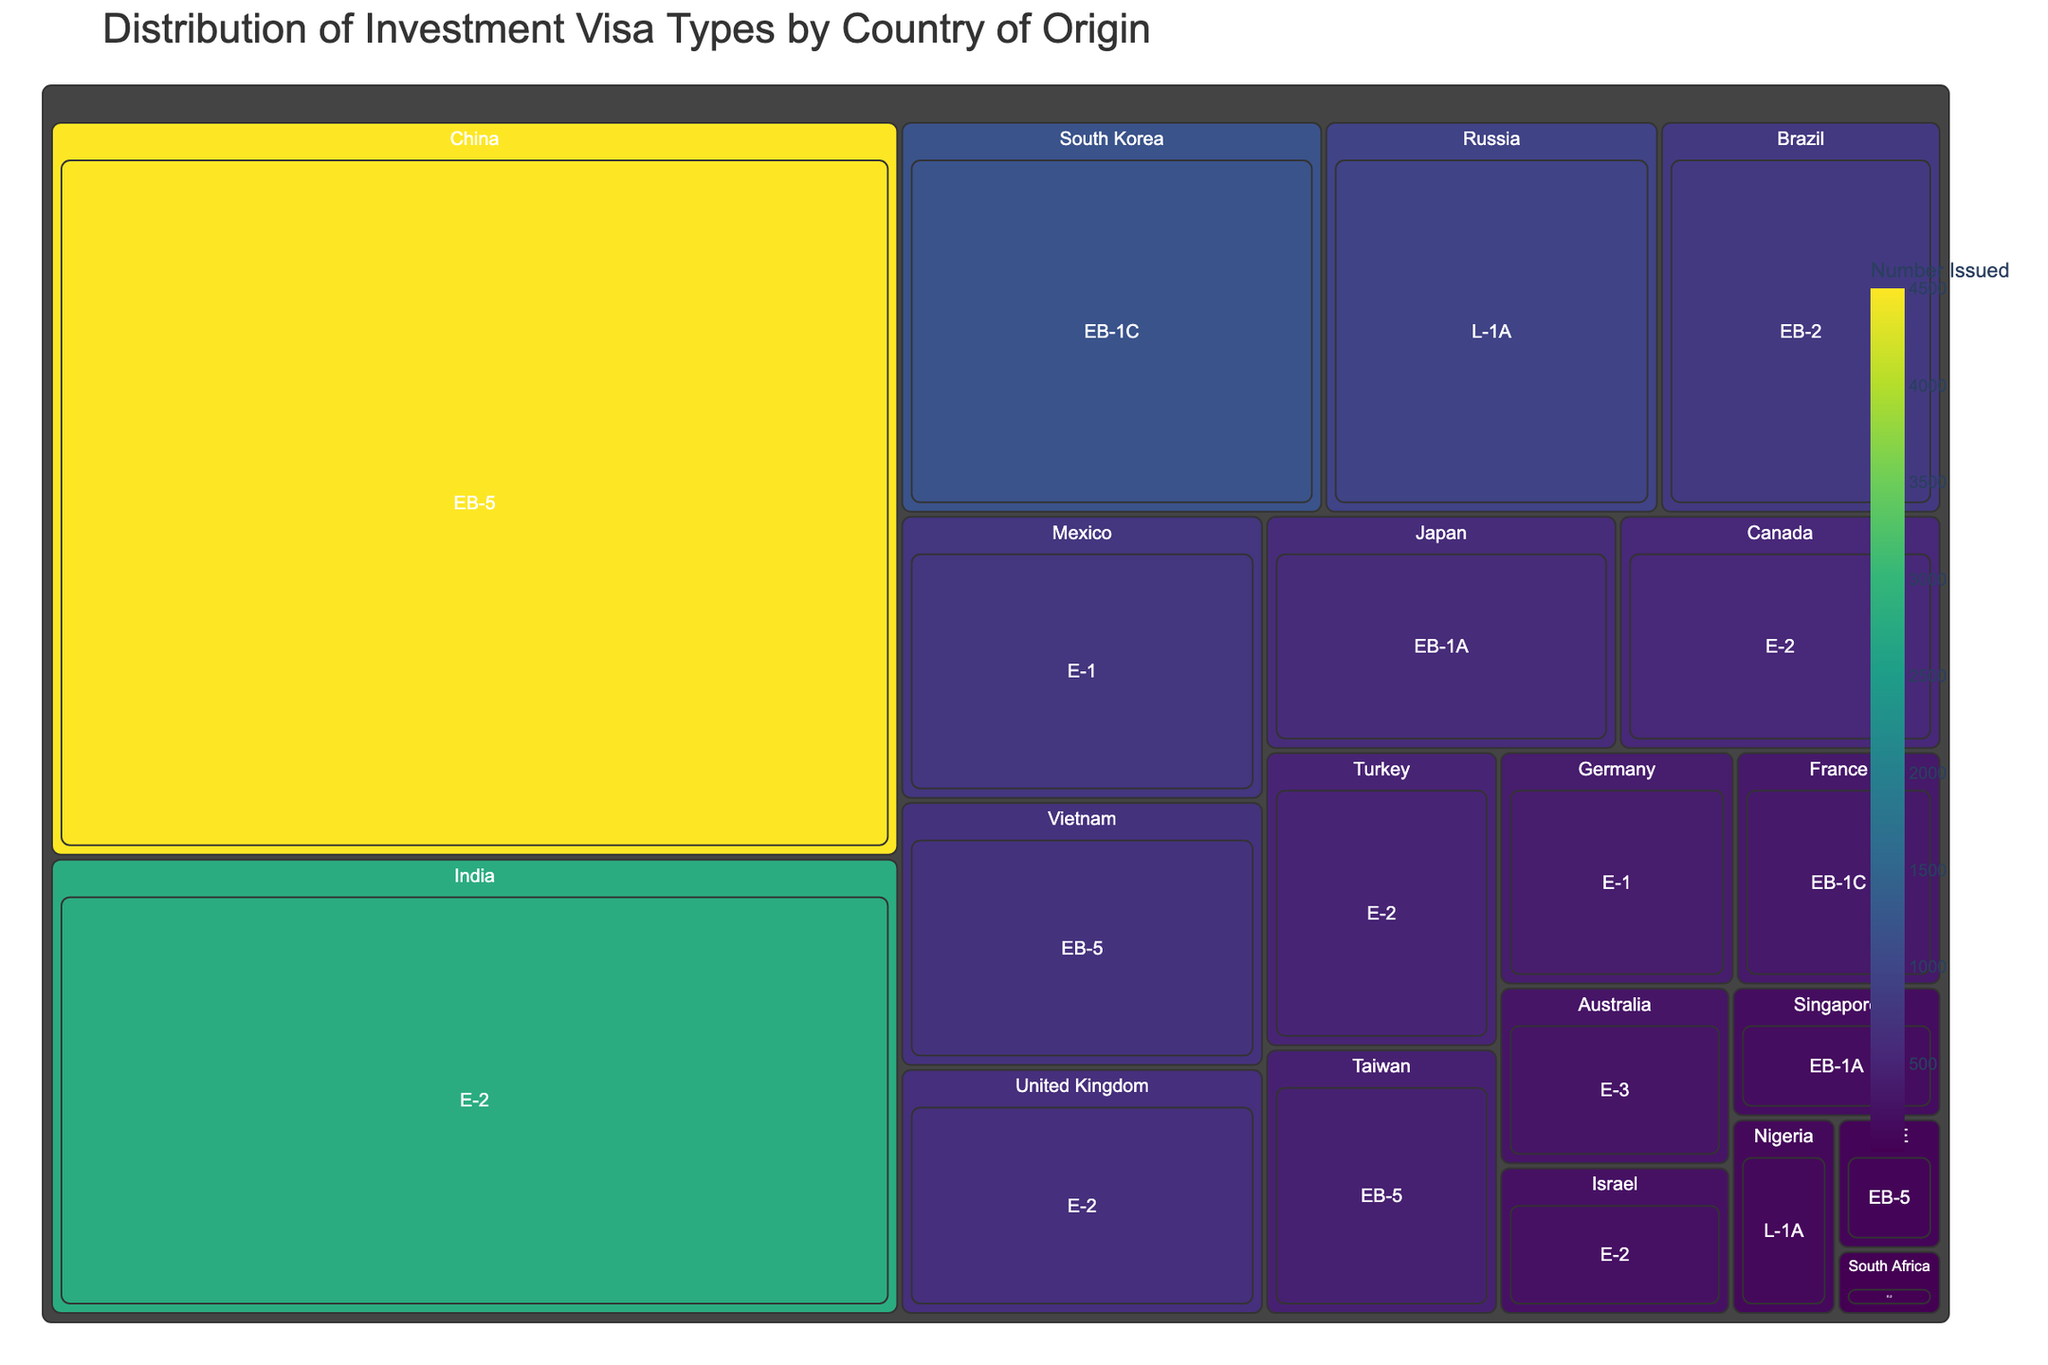What is the title of the treemap? The title is usually placed prominently at the top of the figure. It's used to give viewers a quick overview of what the chart represents.
Answer: Distribution of Investment Visa Types by Country of Origin Which country has the highest number of issued investment visas? By looking at the size of the areas in the treemap, the country with the largest area corresponds to the highest number of issued visas.
Answer: China How many E-2 visas were issued for investors from the United Kingdom? Check the area labeled 'United Kingdom' and look at the count associated with 'E-2' within that section.
Answer: 650 Which visa type has the highest number of visas issued to Chinese investors? Locate China on the treemap and identify the visa type with the largest area within China's section.
Answer: EB-5 Compare the number of EB-1A visas issued to Japanese investors with those issued to Singaporean investors. Which is higher? Identify the areas for Japan and Singapore, then within each, find the EB-1A visa counts and compare them.
Answer: Japan What is the total number of L-1A visas issued across all countries? Add up the L-1A visa numbers from the relevant countries: Russia (950) and Nigeria (150).
Answer: 1100 Which country is the smallest contributor of E-2 visas? Find all segments for E-2 visas and identify the country with the smallest area within those segments.
Answer: South Africa How does the number of EB-1C visas issued to South Korean investors compare to those issued to French investors? Locate South Korea and France on the treemap and compare the EB-1C visa numbers.
Answer: South Korea has more Determine the percentage of EB-5 visas issued to Taiwanese investors compared to Chinese investors. Calculate the share by dividing Taiwan's EB-5 number by China's EB-5 number and then multiply by 100: (450/4500) * 100.
Answer: 10% Which visa type is most common among investors from Mexico? Look at the Mexico section of the treemap and note which visa type has the largest area.
Answer: E-1 